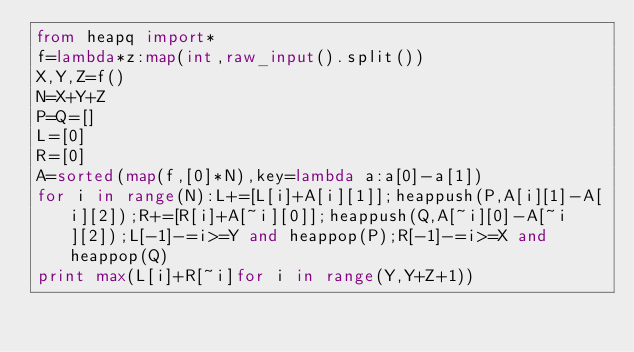Convert code to text. <code><loc_0><loc_0><loc_500><loc_500><_Python_>from heapq import*
f=lambda*z:map(int,raw_input().split())
X,Y,Z=f()
N=X+Y+Z
P=Q=[]
L=[0]
R=[0]
A=sorted(map(f,[0]*N),key=lambda a:a[0]-a[1])
for i in range(N):L+=[L[i]+A[i][1]];heappush(P,A[i][1]-A[i][2]);R+=[R[i]+A[~i][0]];heappush(Q,A[~i][0]-A[~i][2]);L[-1]-=i>=Y and heappop(P);R[-1]-=i>=X and heappop(Q)
print max(L[i]+R[~i]for i in range(Y,Y+Z+1))</code> 